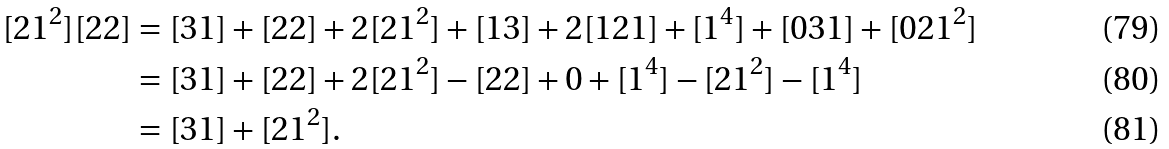Convert formula to latex. <formula><loc_0><loc_0><loc_500><loc_500>[ 2 1 ^ { 2 } ] [ 2 2 ] & = [ 3 1 ] + [ 2 2 ] + 2 [ 2 1 ^ { 2 } ] + [ 1 3 ] + 2 [ 1 2 1 ] + [ 1 ^ { 4 } ] + [ 0 3 1 ] + [ 0 2 1 ^ { 2 } ] \\ & = [ 3 1 ] + [ 2 2 ] + 2 [ 2 1 ^ { 2 } ] - [ 2 2 ] + 0 + [ 1 ^ { 4 } ] - [ 2 1 ^ { 2 } ] - [ 1 ^ { 4 } ] \\ & = [ 3 1 ] + [ 2 1 ^ { 2 } ] .</formula> 